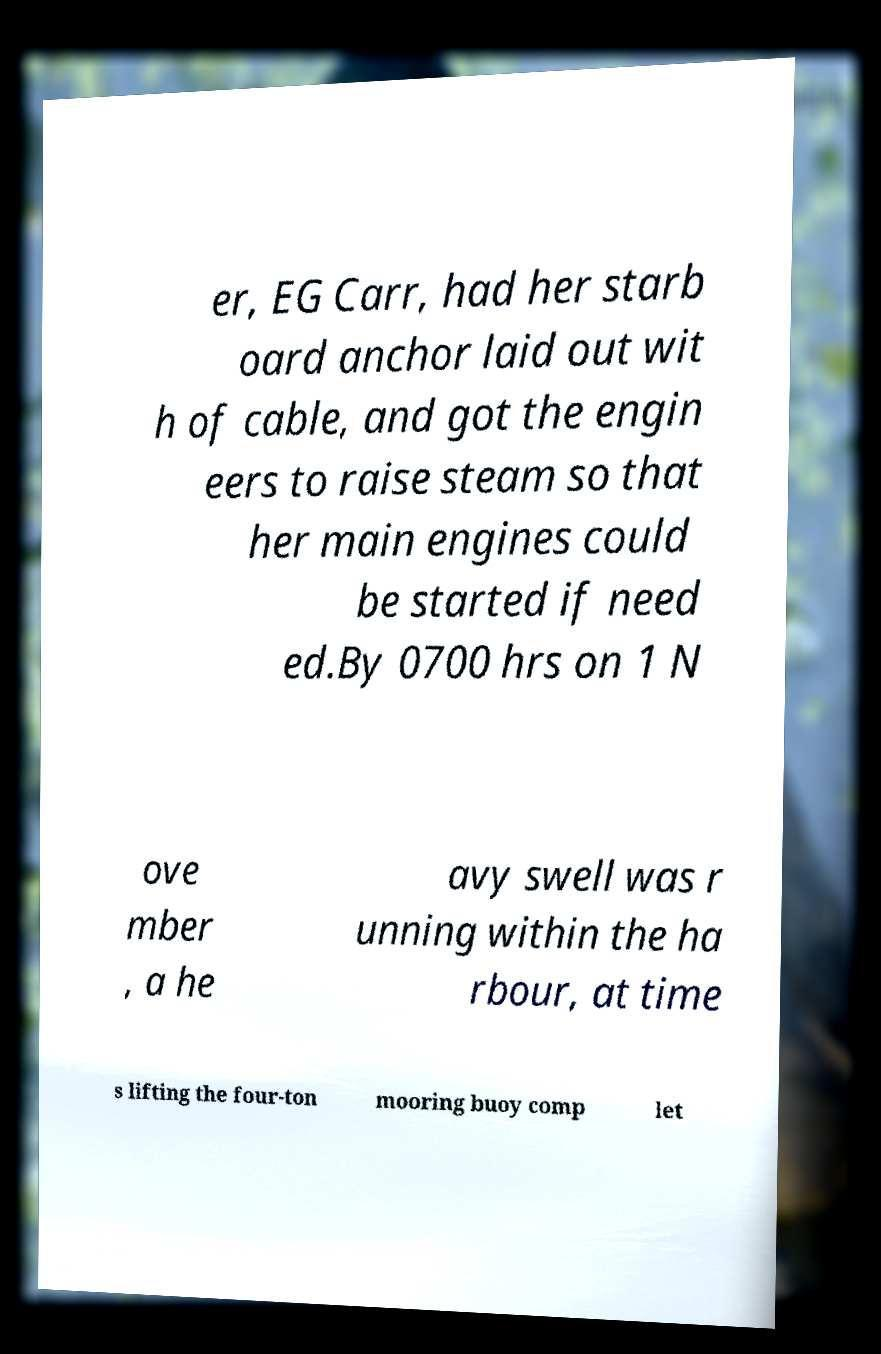Can you accurately transcribe the text from the provided image for me? er, EG Carr, had her starb oard anchor laid out wit h of cable, and got the engin eers to raise steam so that her main engines could be started if need ed.By 0700 hrs on 1 N ove mber , a he avy swell was r unning within the ha rbour, at time s lifting the four-ton mooring buoy comp let 